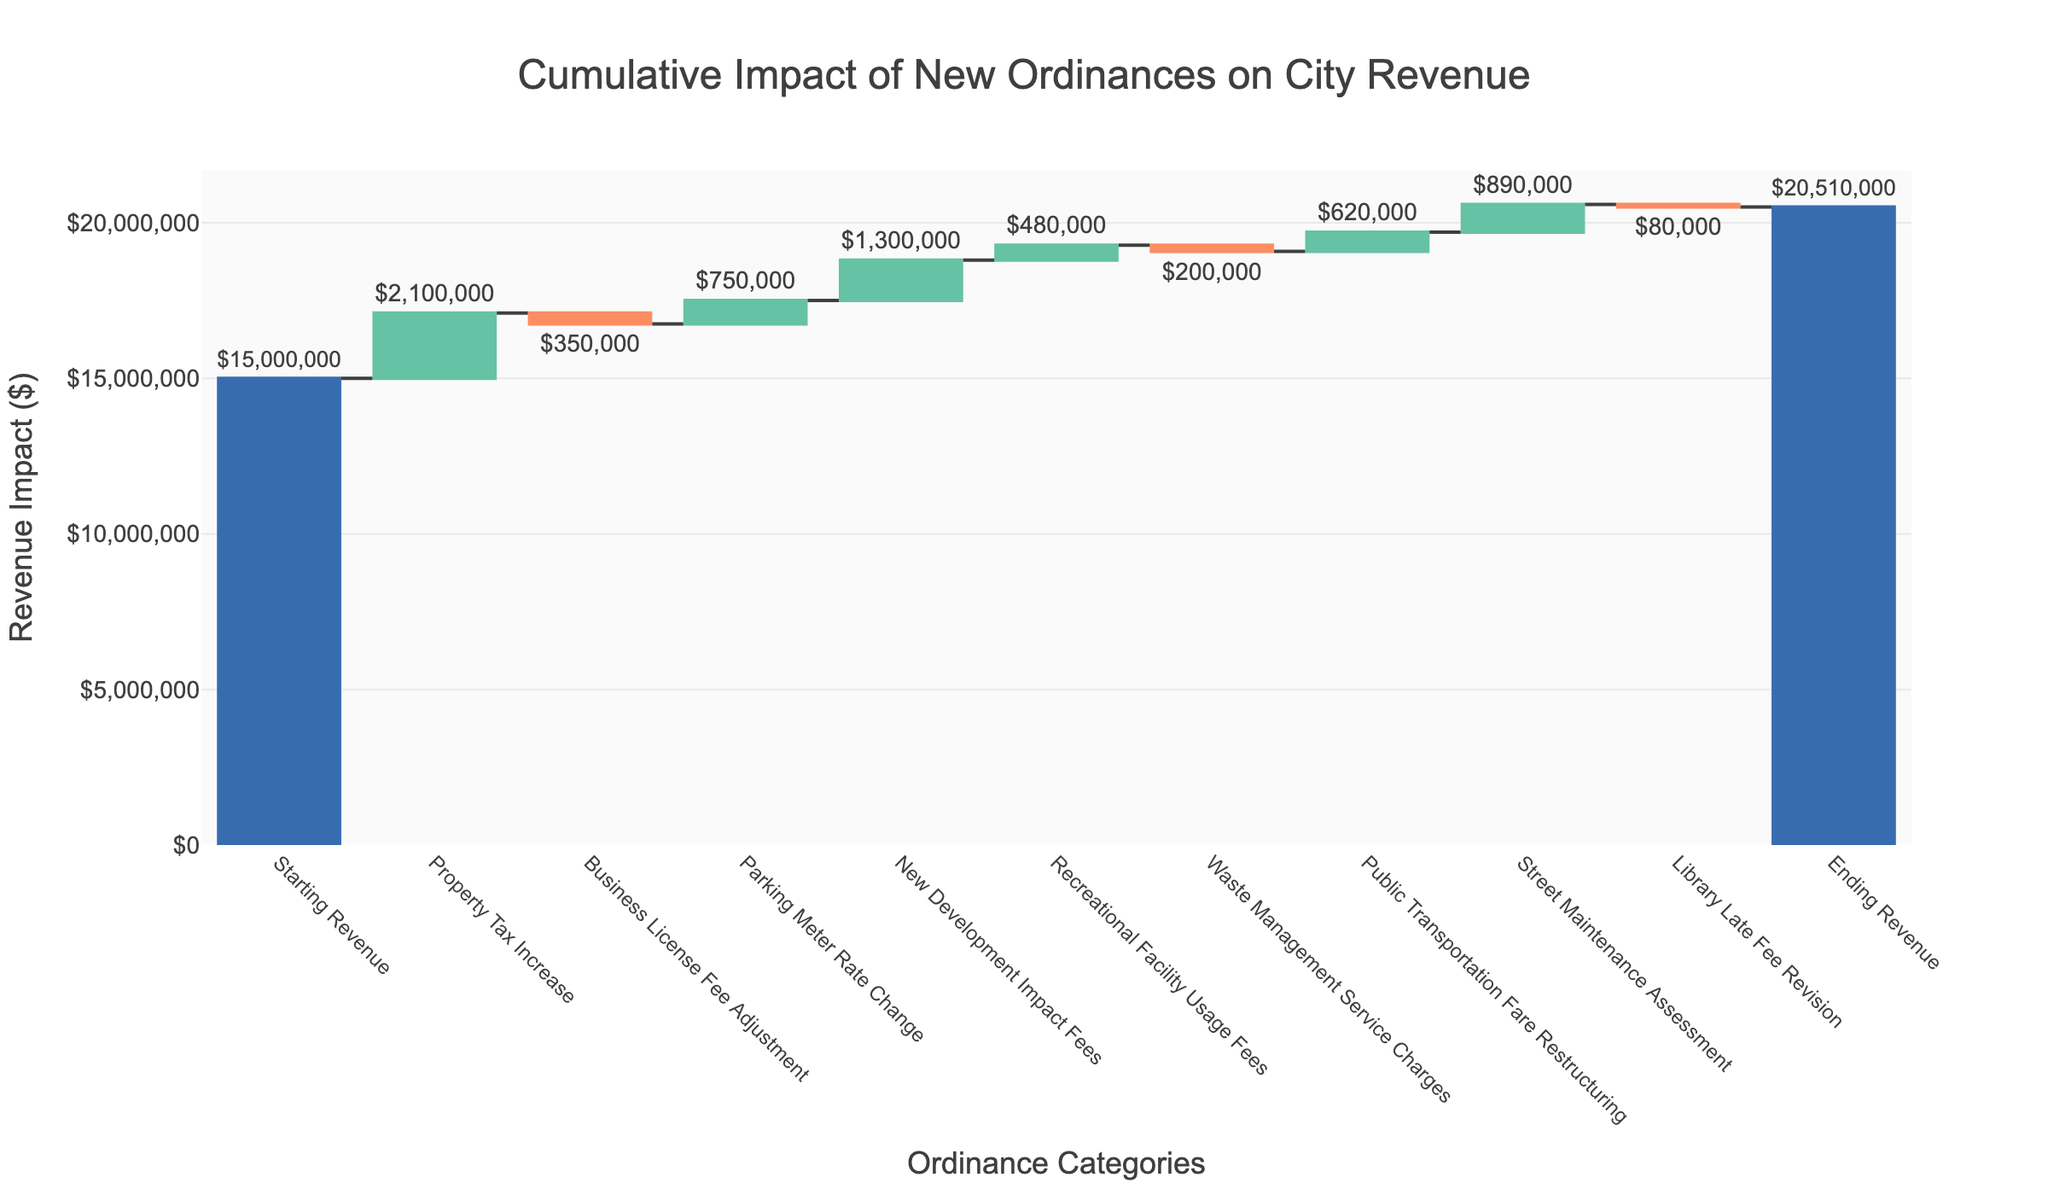*What is the title of the figure?* The title of the figure can be located at the top center. It reads, "Cumulative Impact of New Ordinances on City Revenue."
Answer: Cumulative Impact of New Ordinances on City Revenue *What is the starting revenue according to the figure?* The first bar in the waterfall chart represents the starting revenue. It is labeled "Starting Revenue" and has a value of $15,000,000.
Answer: $15,000,000 *How much did the property tax increase impact revenue?* The bar labeled "Property Tax Increase" shows the revenue impact. It has an increment of $2,100,000.
Answer: $2,100,000 *What is the cumulative revenue after applying all ordinances?* The last bar in the waterfall chart represents the ending revenue. It is labeled "Ending Revenue" and has a value of $20,510,000.
Answer: $20,510,000 *How many ordinance categories contributed positively to the revenue?* Count the number of bars with positive impacts aside from the starting and ending revenues. These are "Property Tax Increase", "Parking Meter Rate Change", "New Development Impact Fees", "Recreational Facility Usage Fees", "Public Transportation Fare Restructuring", and "Street Maintenance Assessment." There are 6 positive contributors.
Answer: 6 *What is the smallest negative impact on the revenue?* Among the negative impact bars, "Library Late Fee Revision" has the smallest value, which is a reduction of $80,000.
Answer: $80,000 *What is the net impact of negative ordinances on the revenue?* The negative contributions are: Business License Fee Adjustment (-$350,000), Waste Management Service Charges (-$200,000), and Library Late Fee Revision (-$80,000). Summing these up: -$350,000 + (-$200,000) + (-$80,000) = -$630,000.
Answer: -$630,000 *Between "Parking Meter Rate Change" and "New Development Impact Fees," which contributed more to the revenue?* "New Development Impact Fees" contributed $1,300,000 while "Parking Meter Rate Change" contributed $750,000. A comparison shows that "New Development Impact Fees" contributed more.
Answer: New Development Impact Fees *What is the total positive impact on the revenue from all ordinances?* Adding all positive impacts: Property Tax Increase ($2,100,000) + Parking Meter Rate Change ($750,000) + New Development Impact Fees ($1,300,000) + Recreational Facility Usage Fees ($480,000) + Public Transportation Fare Restructuring ($620,000) + Street Maintenance Assessment ($890,000). Summing these values: $2,100,000 + $750,000 + $1,300,000 + $480,000 + $620,000 + $890,000 = $6,140,000.
Answer: $6,140,000 